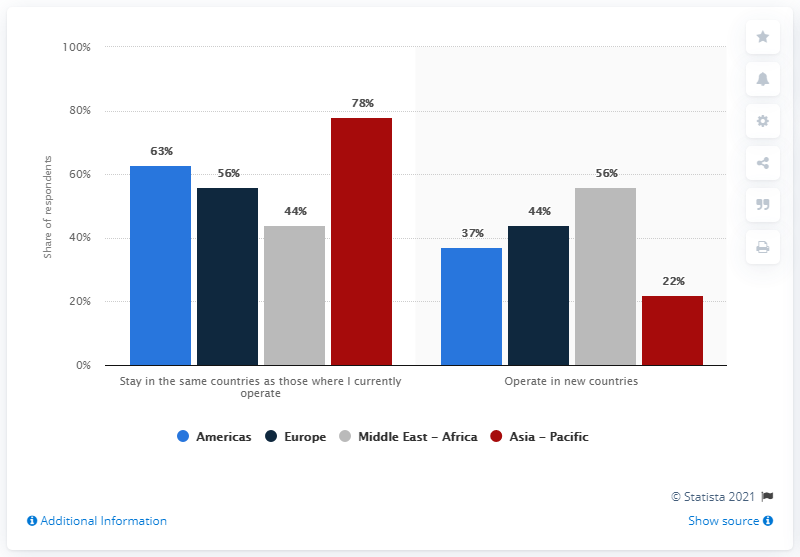List a handful of essential elements in this visual. The average of the two strategic priorities is 1.51572327... The value of the shortest bar is 22. 